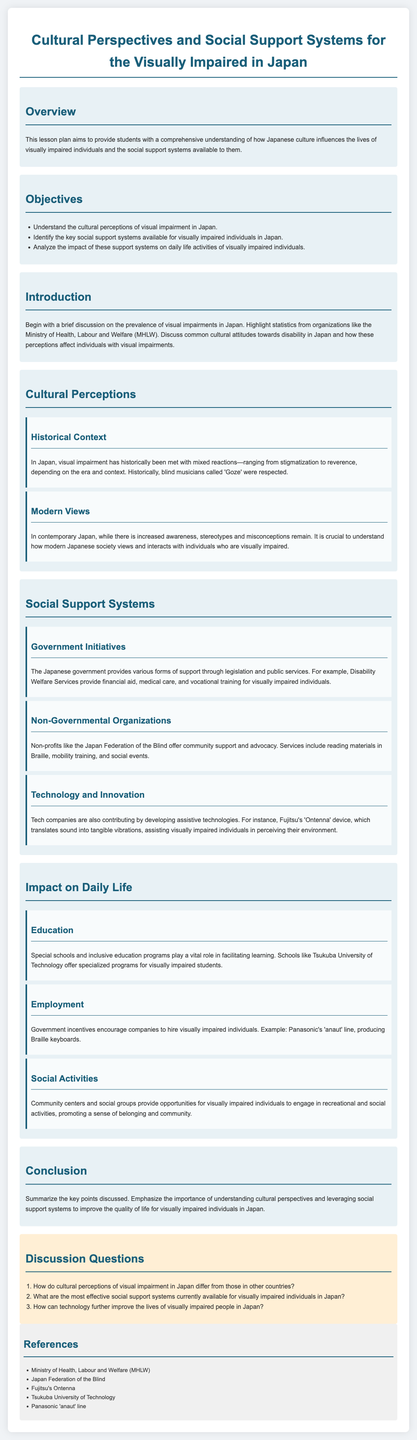What is the purpose of this lesson plan? The lesson plan aims to provide students with a comprehensive understanding of how Japanese culture influences the lives of visually impaired individuals and the social support systems available to them.
Answer: Understanding cultural influences and social support systems What are the three key objectives listed in the document? The objectives are to understand cultural perceptions, identify support systems, and analyze their impact on daily life activities.
Answer: Understand cultural perceptions, Identify support systems, Analyze impact What historical role did 'Goze' play in Japan? 'Goze' were blind musicians who were historically respected in Japan, reflecting mixed societal reactions to visual impairment.
Answer: Respected blind musicians What type of support do Disability Welfare Services provide? The services include financial aid, medical care, and vocational training for visually impaired individuals.
Answer: Financial aid, medical care, vocational training Which organization offers community support for the visually impaired? The Japan Federation of the Blind provides services like reading materials in Braille and mobility training.
Answer: Japan Federation of the Blind How does technology contribute to supporting visually impaired individuals in Japan? Tech companies develop assistive technologies like Fujitsu's 'Ontenna', which assists visually impaired individuals in perceiving their environment through sound-to-vibration translation.
Answer: Assistive technologies What impact do special schools have on the education of visually impaired students? Special schools and inclusive education programs facilitate learning for visually impaired students, enhancing their educational experiences.
Answer: Facilitate learning What is one government initiative encouraging employment for visually impaired individuals? The document mentions incentives for companies to hire visually impaired individuals, like Panasonic's 'anaut' line that produces Braille keyboards.
Answer: Panasonic's 'anaut' line What social benefit do community centers provide for visually impaired people? Community centers provide opportunities for engaging in recreational and social activities, promoting a sense of belonging.
Answer: Recreational and social activities 